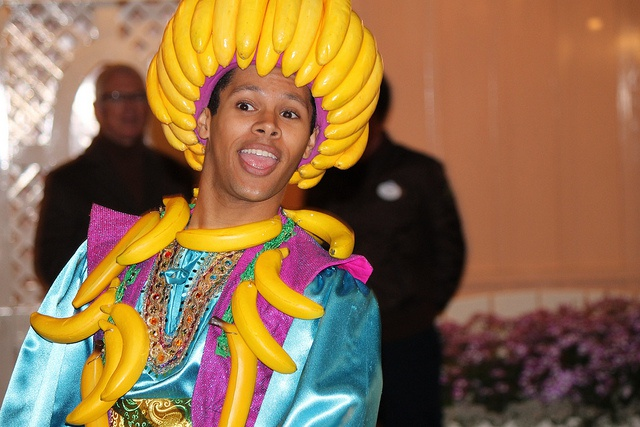Describe the objects in this image and their specific colors. I can see people in darkgray, orange, gold, and brown tones, people in darkgray, black, maroon, gray, and brown tones, people in darkgray, black, maroon, brown, and gray tones, banana in darkgray, orange, gold, and lightblue tones, and banana in darkgray, orange, gold, and olive tones in this image. 